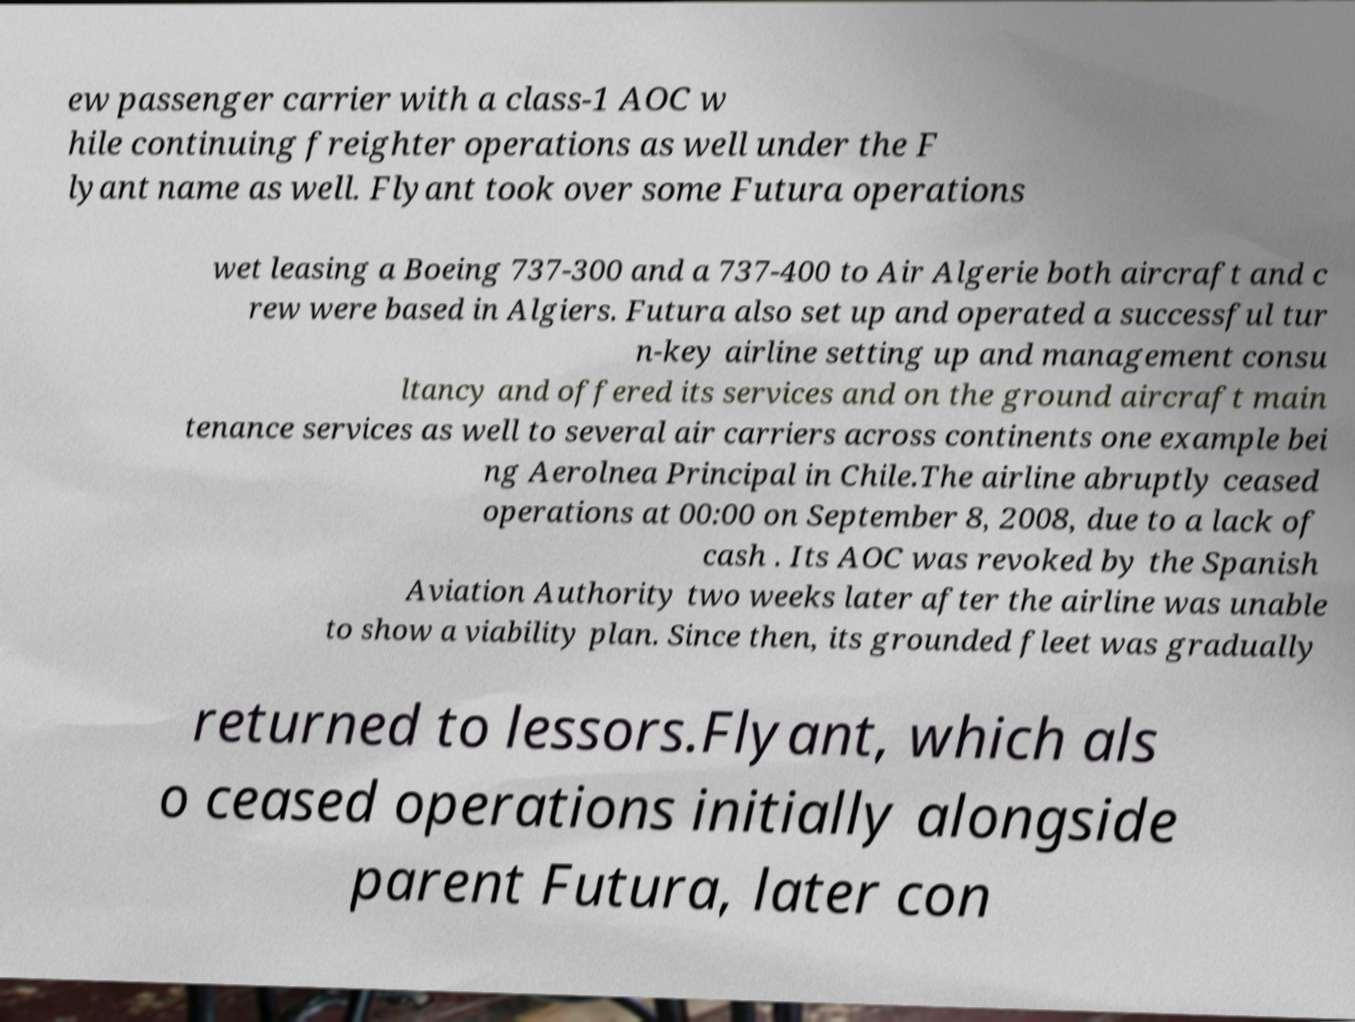What messages or text are displayed in this image? I need them in a readable, typed format. ew passenger carrier with a class-1 AOC w hile continuing freighter operations as well under the F lyant name as well. Flyant took over some Futura operations wet leasing a Boeing 737-300 and a 737-400 to Air Algerie both aircraft and c rew were based in Algiers. Futura also set up and operated a successful tur n-key airline setting up and management consu ltancy and offered its services and on the ground aircraft main tenance services as well to several air carriers across continents one example bei ng Aerolnea Principal in Chile.The airline abruptly ceased operations at 00:00 on September 8, 2008, due to a lack of cash . Its AOC was revoked by the Spanish Aviation Authority two weeks later after the airline was unable to show a viability plan. Since then, its grounded fleet was gradually returned to lessors.Flyant, which als o ceased operations initially alongside parent Futura, later con 